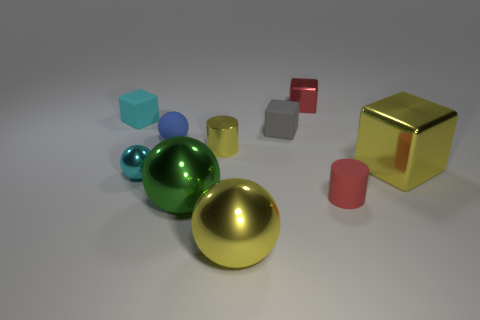Subtract 1 spheres. How many spheres are left? 3 Subtract all green balls. How many balls are left? 3 Subtract all purple spheres. Subtract all gray cubes. How many spheres are left? 4 Subtract all cylinders. How many objects are left? 8 Add 8 big green metal objects. How many big green metal objects are left? 9 Add 4 cyan cubes. How many cyan cubes exist? 5 Subtract 0 gray cylinders. How many objects are left? 10 Subtract all tiny blue objects. Subtract all yellow metallic balls. How many objects are left? 8 